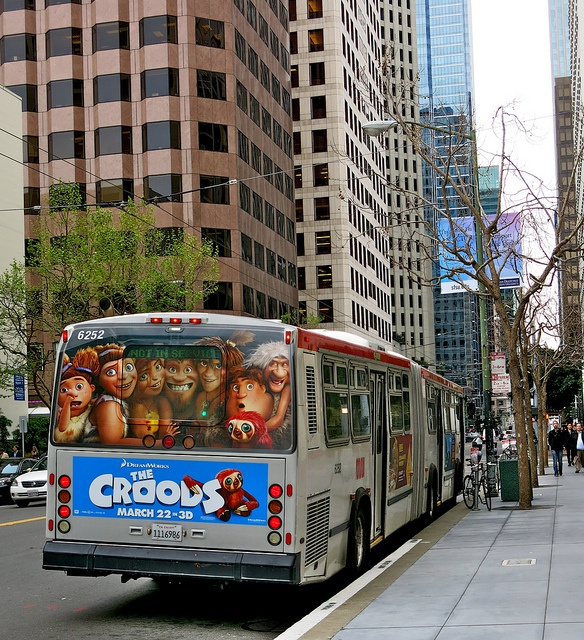Describe the objects in this image and their specific colors. I can see bus in black, gray, darkgray, and maroon tones, car in black, lightgray, gray, and darkgray tones, bicycle in black, gray, darkgray, and lightgray tones, car in black, gray, and lightblue tones, and people in black, navy, gray, and blue tones in this image. 